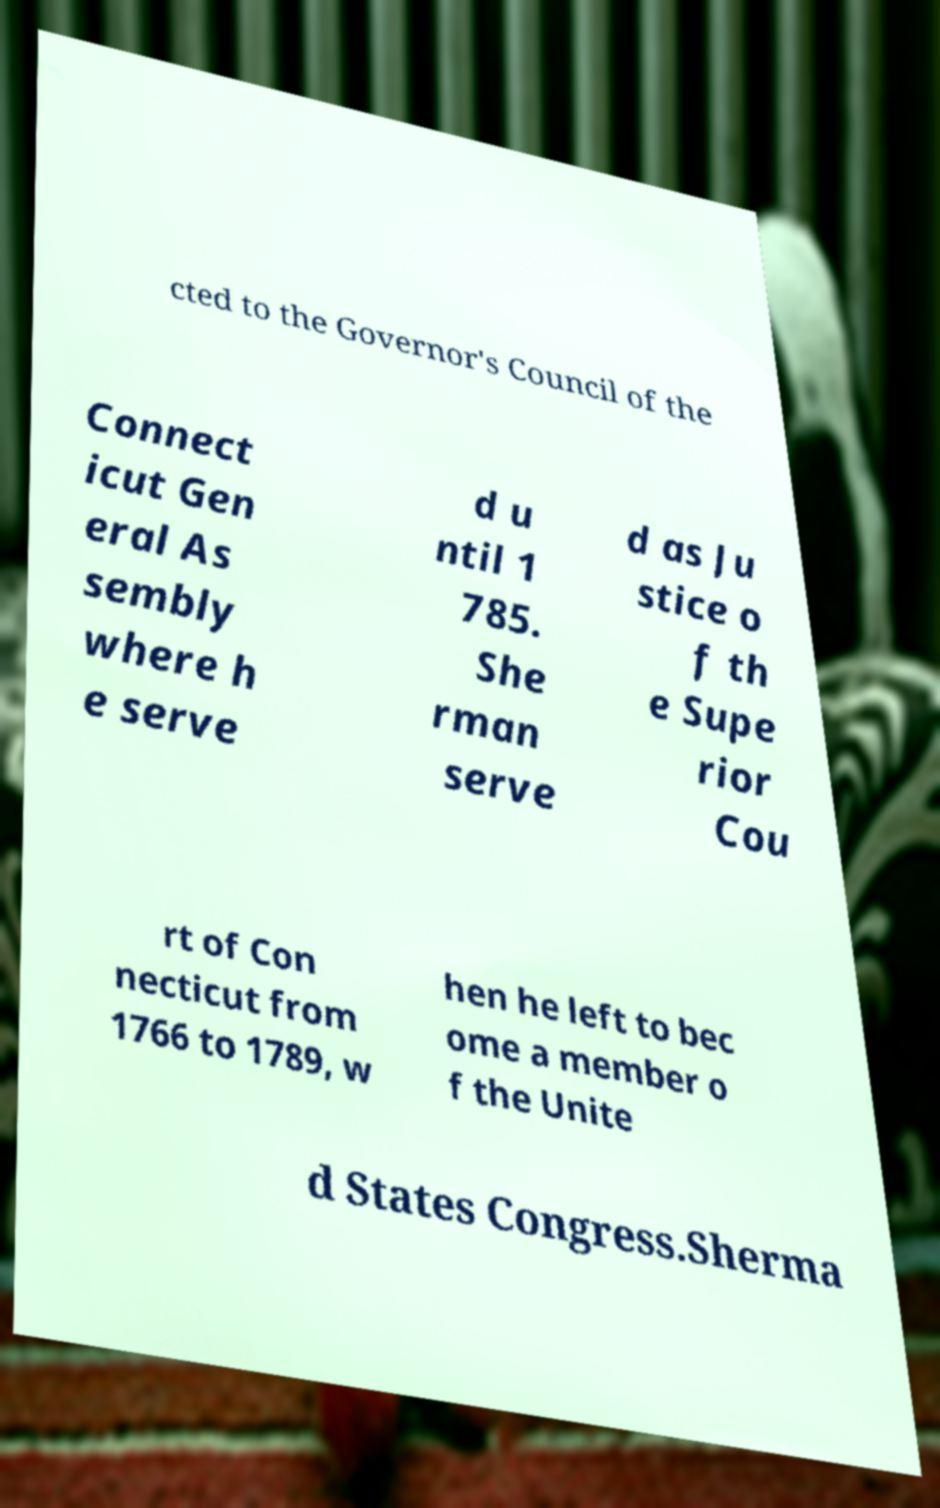There's text embedded in this image that I need extracted. Can you transcribe it verbatim? cted to the Governor's Council of the Connect icut Gen eral As sembly where h e serve d u ntil 1 785. She rman serve d as Ju stice o f th e Supe rior Cou rt of Con necticut from 1766 to 1789, w hen he left to bec ome a member o f the Unite d States Congress.Sherma 